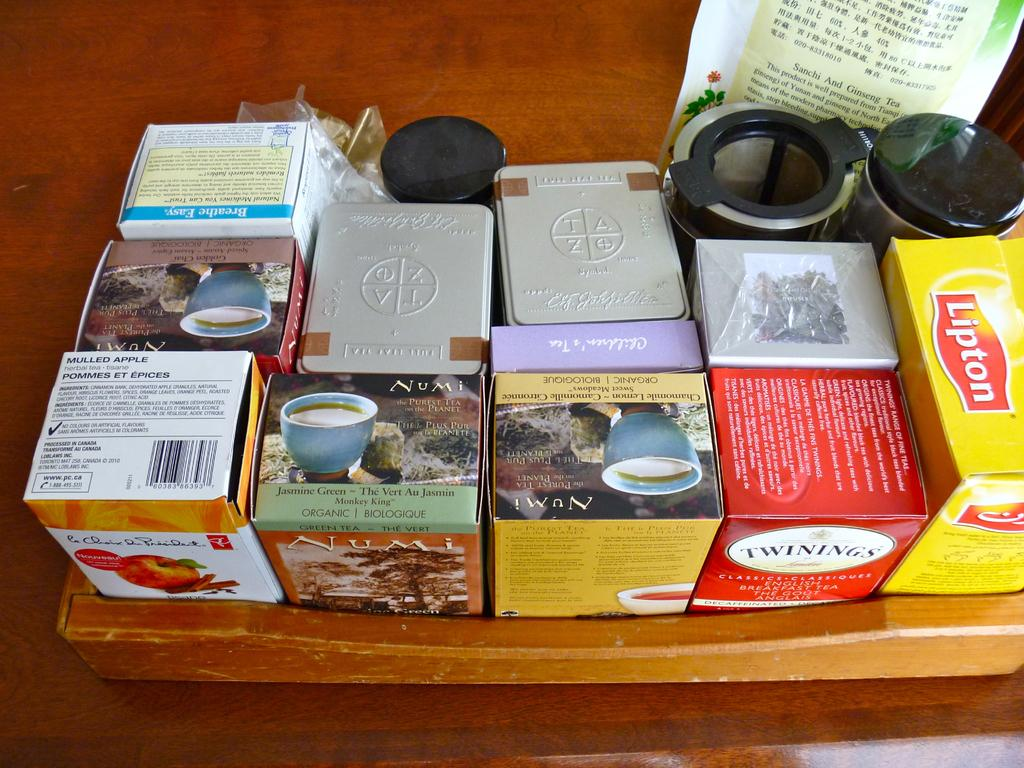<image>
Create a compact narrative representing the image presented. several boxes of tea in a tray include Lipton 